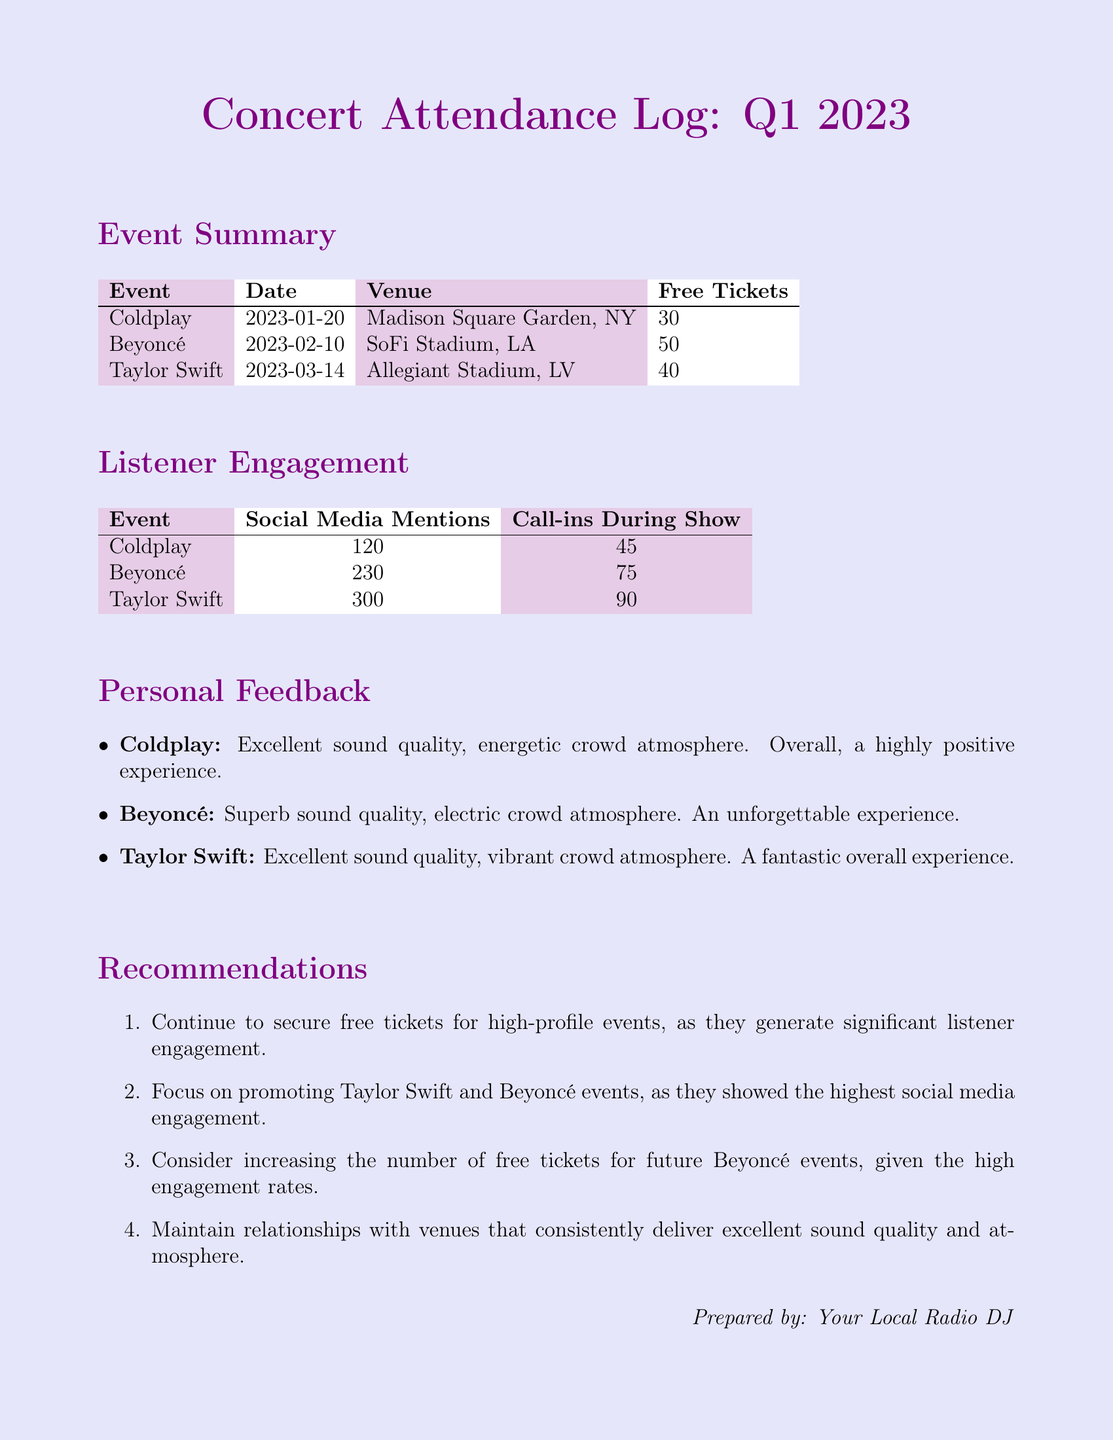What was the date of the Coldplay concert? The date is listed in the Event Summary section of the document as January 20, 2023.
Answer: January 20, 2023 How many free tickets were distributed for the Beyoncé concert? The number of free tickets for the Beyoncé concert is specified in the Event Summary table.
Answer: 50 Which event had the highest number of social media mentions? The Listener Engagement table indicates the social media mentions for each event, showing that Taylor Swift had the highest.
Answer: 300 What venue hosted the Taylor Swift concert? The venue for the Taylor Swift concert is given in the Event Summary section.
Answer: Allegiant Stadium, LV What was the feedback for the Coldplay concert? Personal Feedback section of the document provides insights on the Coldplay concert experience.
Answer: Excellent sound quality, energetic crowd atmosphere Which concert had the most call-ins during the show? The number of call-ins is recorded in the Listener Engagement section, with Beyoncé having the highest quantity.
Answer: 75 Which artist had the greatest listener engagement overall? Reasoning from both social media mentions and call-ins reveals Beyoncé as having high engagement.
Answer: Beyoncé How many free tickets were distributed for the Taylor Swift concert? The Event Summary table includes the count of free tickets for the Taylor Swift concert.
Answer: 40 What is one recommendation provided in the document? The Recommendations section lists strategies to enhance future concert attendance and engagement.
Answer: Continue to secure free tickets for high-profile events 